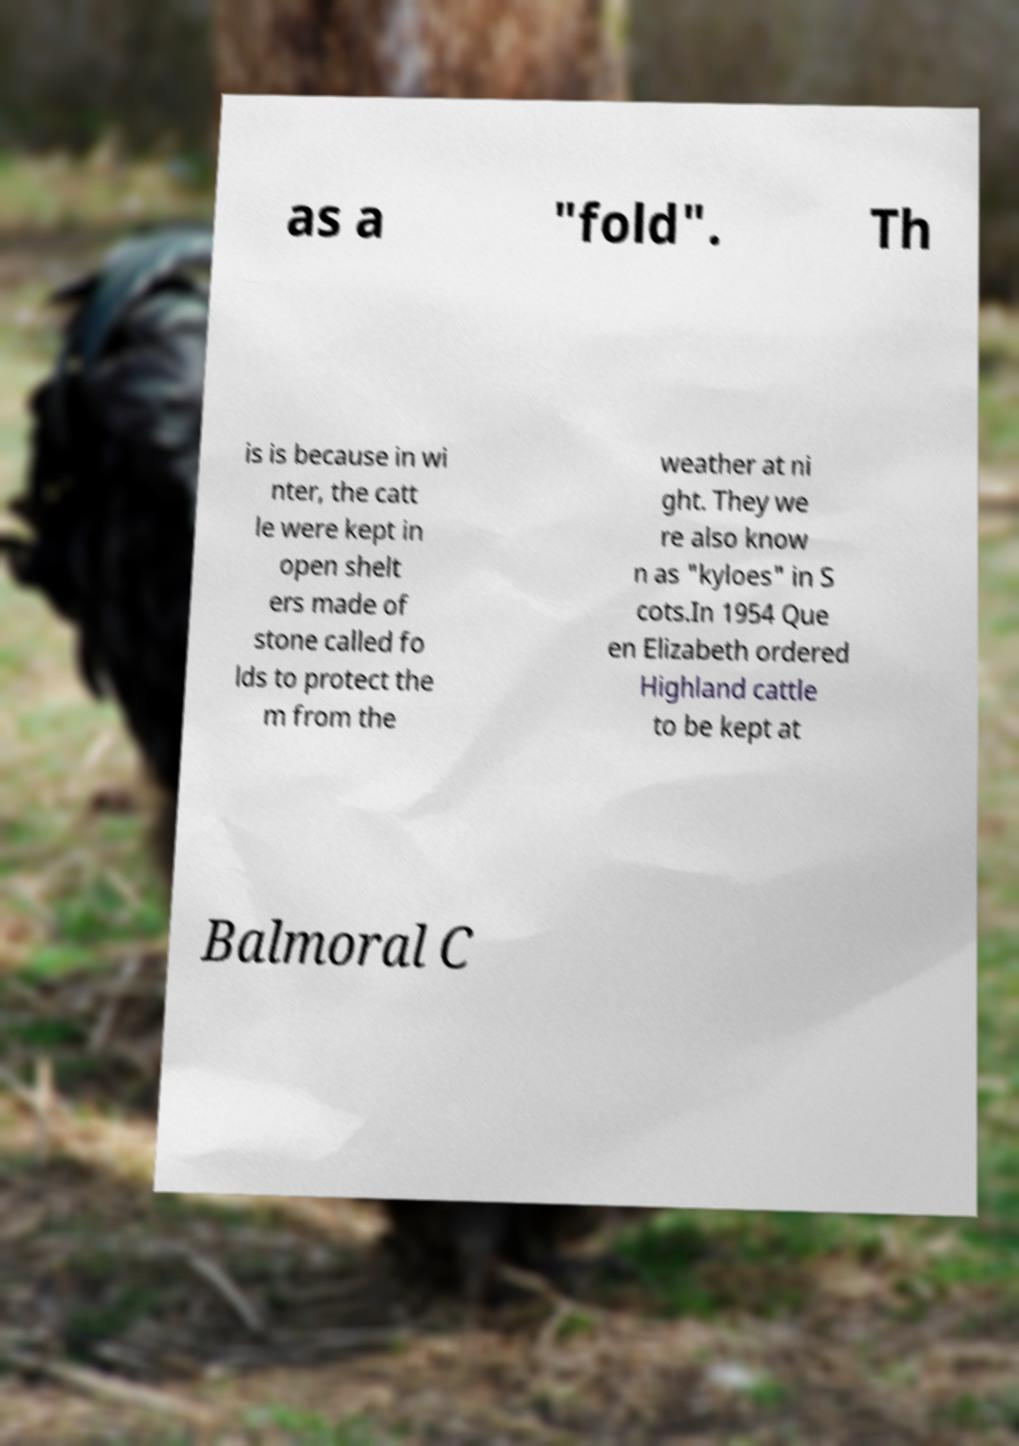What messages or text are displayed in this image? I need them in a readable, typed format. as a "fold". Th is is because in wi nter, the catt le were kept in open shelt ers made of stone called fo lds to protect the m from the weather at ni ght. They we re also know n as "kyloes" in S cots.In 1954 Que en Elizabeth ordered Highland cattle to be kept at Balmoral C 